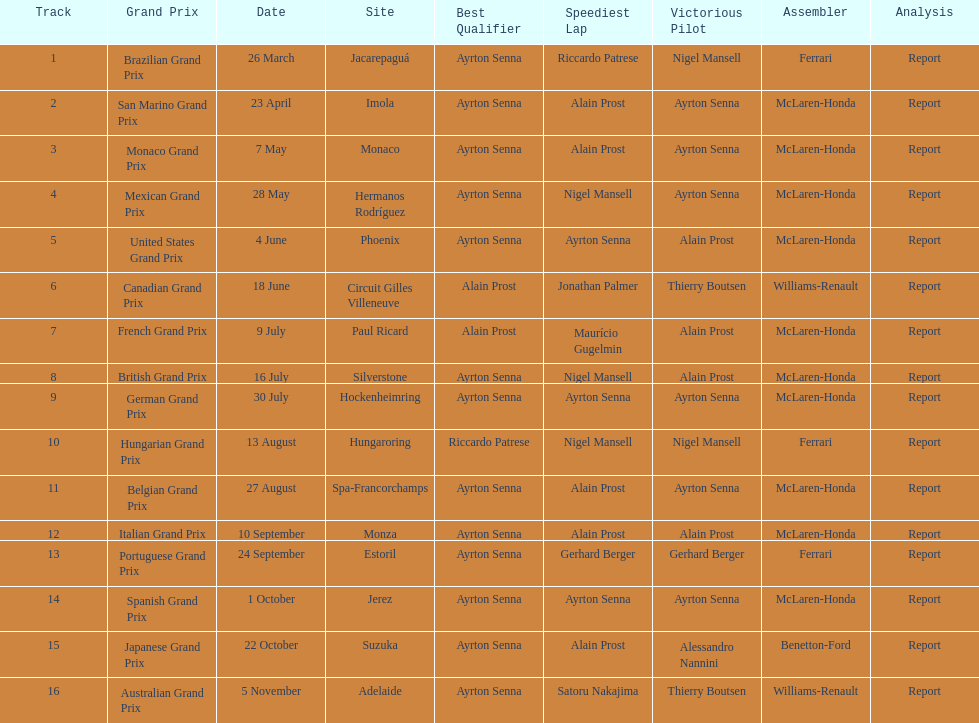Prost won the drivers title, who was his teammate? Ayrton Senna. 